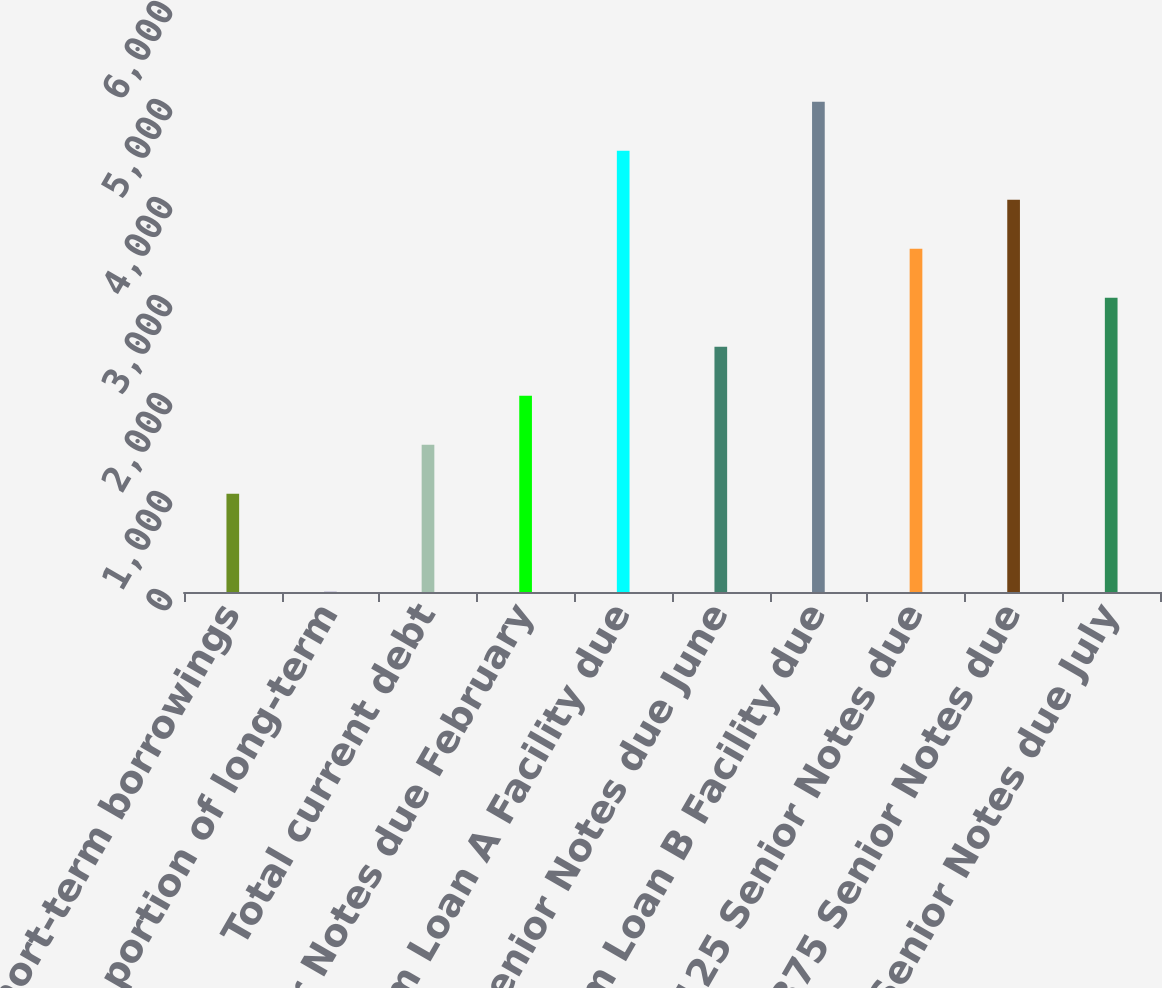Convert chart to OTSL. <chart><loc_0><loc_0><loc_500><loc_500><bar_chart><fcel>Short-term borrowings<fcel>Current portion of long-term<fcel>Total current debt<fcel>12 Senior Notes due February<fcel>Term Loan A Facility due<fcel>7875 Senior Notes due June<fcel>Term Loan B Facility due<fcel>8125 Senior Notes due<fcel>8375 Senior Notes due<fcel>6875 Senior Notes due July<nl><fcel>1002.14<fcel>1.9<fcel>1502.26<fcel>2002.38<fcel>4502.98<fcel>2502.5<fcel>5003.1<fcel>3502.74<fcel>4002.86<fcel>3002.62<nl></chart> 